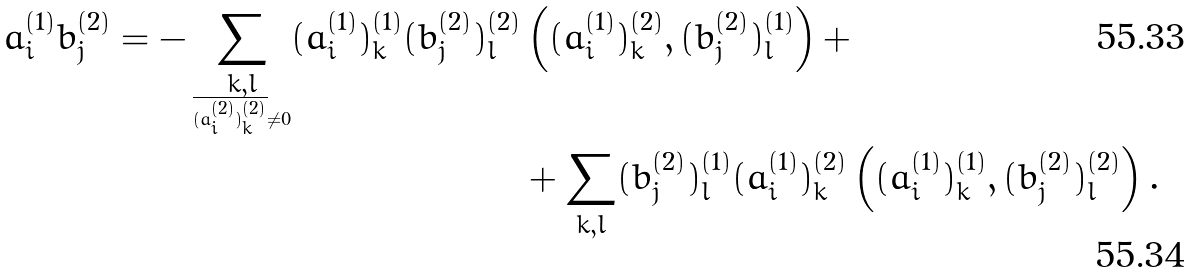<formula> <loc_0><loc_0><loc_500><loc_500>a _ { i } ^ { ( 1 ) } b _ { j } ^ { ( 2 ) } = - \sum _ { \underset { \overline { ( a _ { i } ^ { ( 2 ) } ) _ { k } ^ { ( 2 ) } } \ne 0 } { k , l } } ( a _ { i } ^ { ( 1 ) } ) _ { k } ^ { ( 1 ) } ( b _ { j } ^ { ( 2 ) } ) _ { l } ^ { ( 2 ) } & \left ( ( a _ { i } ^ { ( 1 ) } ) _ { k } ^ { ( 2 ) } , ( b _ { j } ^ { ( 2 ) } ) _ { l } ^ { ( 1 ) } \right ) + \\ & + \sum _ { k , l } ( b _ { j } ^ { ( 2 ) } ) _ { l } ^ { ( 1 ) } ( a _ { i } ^ { ( 1 ) } ) _ { k } ^ { ( 2 ) } \left ( ( a _ { i } ^ { ( 1 ) } ) _ { k } ^ { ( 1 ) } , ( b _ { j } ^ { ( 2 ) } ) _ { l } ^ { ( 2 ) } \right ) .</formula> 